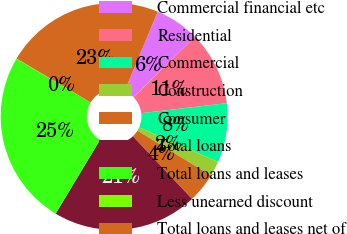<chart> <loc_0><loc_0><loc_500><loc_500><pie_chart><fcel>Commercial financial etc<fcel>Residential<fcel>Commercial<fcel>Construction<fcel>Consumer<fcel>Total loans<fcel>Total loans and leases<fcel>Less unearned discount<fcel>Total loans and leases net of<nl><fcel>6.33%<fcel>10.52%<fcel>8.43%<fcel>2.15%<fcel>4.24%<fcel>20.66%<fcel>24.85%<fcel>0.05%<fcel>22.76%<nl></chart> 